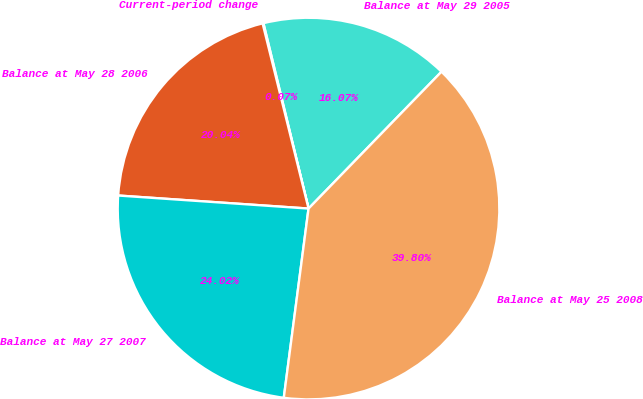Convert chart to OTSL. <chart><loc_0><loc_0><loc_500><loc_500><pie_chart><fcel>Balance at May 29 2005<fcel>Current-period change<fcel>Balance at May 28 2006<fcel>Balance at May 27 2007<fcel>Balance at May 25 2008<nl><fcel>16.07%<fcel>0.07%<fcel>20.04%<fcel>24.02%<fcel>39.8%<nl></chart> 